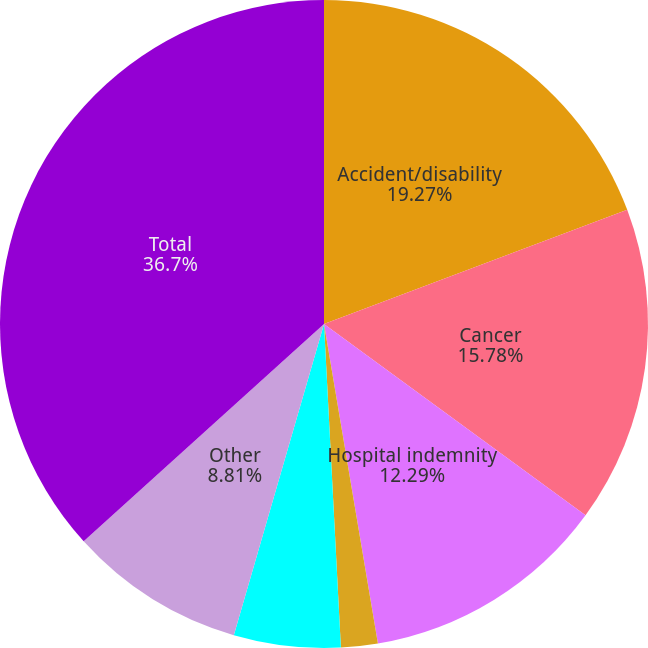Convert chart to OTSL. <chart><loc_0><loc_0><loc_500><loc_500><pie_chart><fcel>Accident/disability<fcel>Cancer<fcel>Hospital indemnity<fcel>Life<fcel>Fixed-benefit dental<fcel>Other<fcel>Total<nl><fcel>19.27%<fcel>15.78%<fcel>12.29%<fcel>1.83%<fcel>5.32%<fcel>8.81%<fcel>36.7%<nl></chart> 